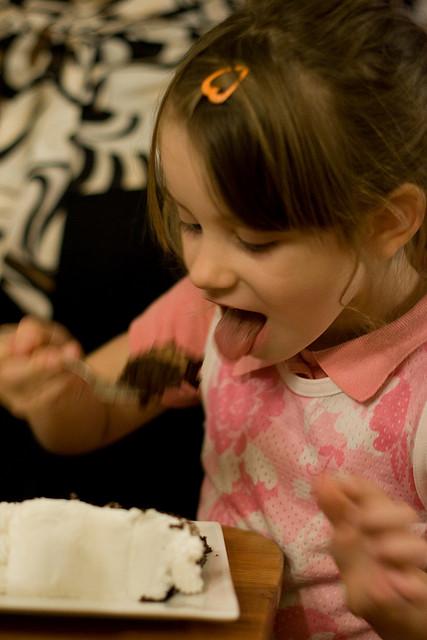Is the girl going to eat the food?
Concise answer only. Yes. What is holding the girls hair out of her face?
Quick response, please. Barrette. What is she eating?
Concise answer only. Cake. 